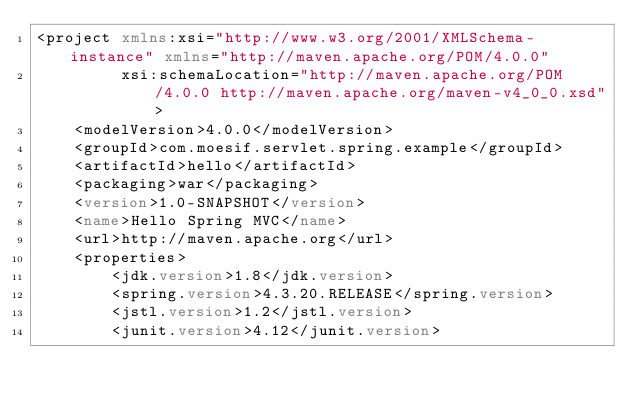Convert code to text. <code><loc_0><loc_0><loc_500><loc_500><_XML_><project xmlns:xsi="http://www.w3.org/2001/XMLSchema-instance" xmlns="http://maven.apache.org/POM/4.0.0"
         xsi:schemaLocation="http://maven.apache.org/POM/4.0.0 http://maven.apache.org/maven-v4_0_0.xsd">
    <modelVersion>4.0.0</modelVersion>
    <groupId>com.moesif.servlet.spring.example</groupId>
    <artifactId>hello</artifactId>
    <packaging>war</packaging>
    <version>1.0-SNAPSHOT</version>
    <name>Hello Spring MVC</name>
    <url>http://maven.apache.org</url>
    <properties>
        <jdk.version>1.8</jdk.version>
        <spring.version>4.3.20.RELEASE</spring.version>
        <jstl.version>1.2</jstl.version>
        <junit.version>4.12</junit.version></code> 